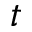<formula> <loc_0><loc_0><loc_500><loc_500>t</formula> 